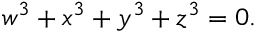<formula> <loc_0><loc_0><loc_500><loc_500>w ^ { 3 } + x ^ { 3 } + y ^ { 3 } + z ^ { 3 } = 0 .</formula> 